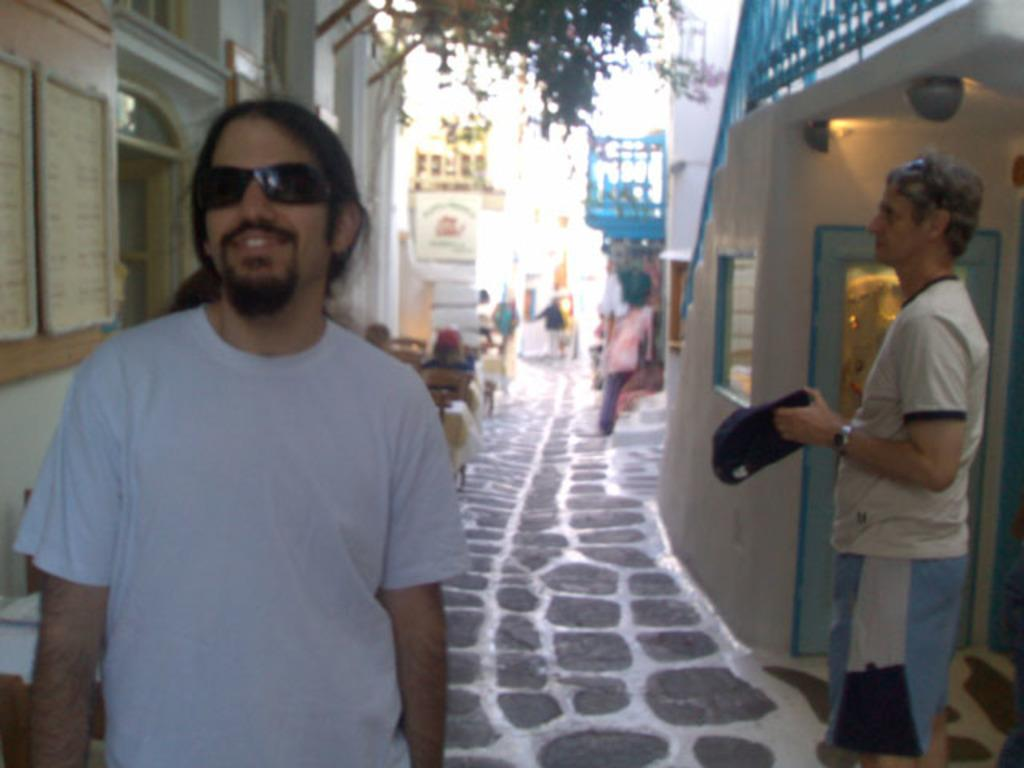How many people are visible in the image? There are two persons standing in the image. What type of structures can be seen in the image? There are buildings in the image. What natural element is present in the image? There is a tree in the image. What objects are used for displaying information in the image? There are boards in the image. What objects provide illumination in the image? There are lights in the image. What objects are used for seating in the image? There are chairs in the image. What objects are used for placing items in the image? There are tables in the image. Are there any other people visible in the image besides the two standing persons? Yes, there are people in the background of the image. What is the condition of the silver in the image? There is no silver present in the image. What fact can be learned about the tree in the image? The fact that there is a tree in the image has already been mentioned in the conversation. 